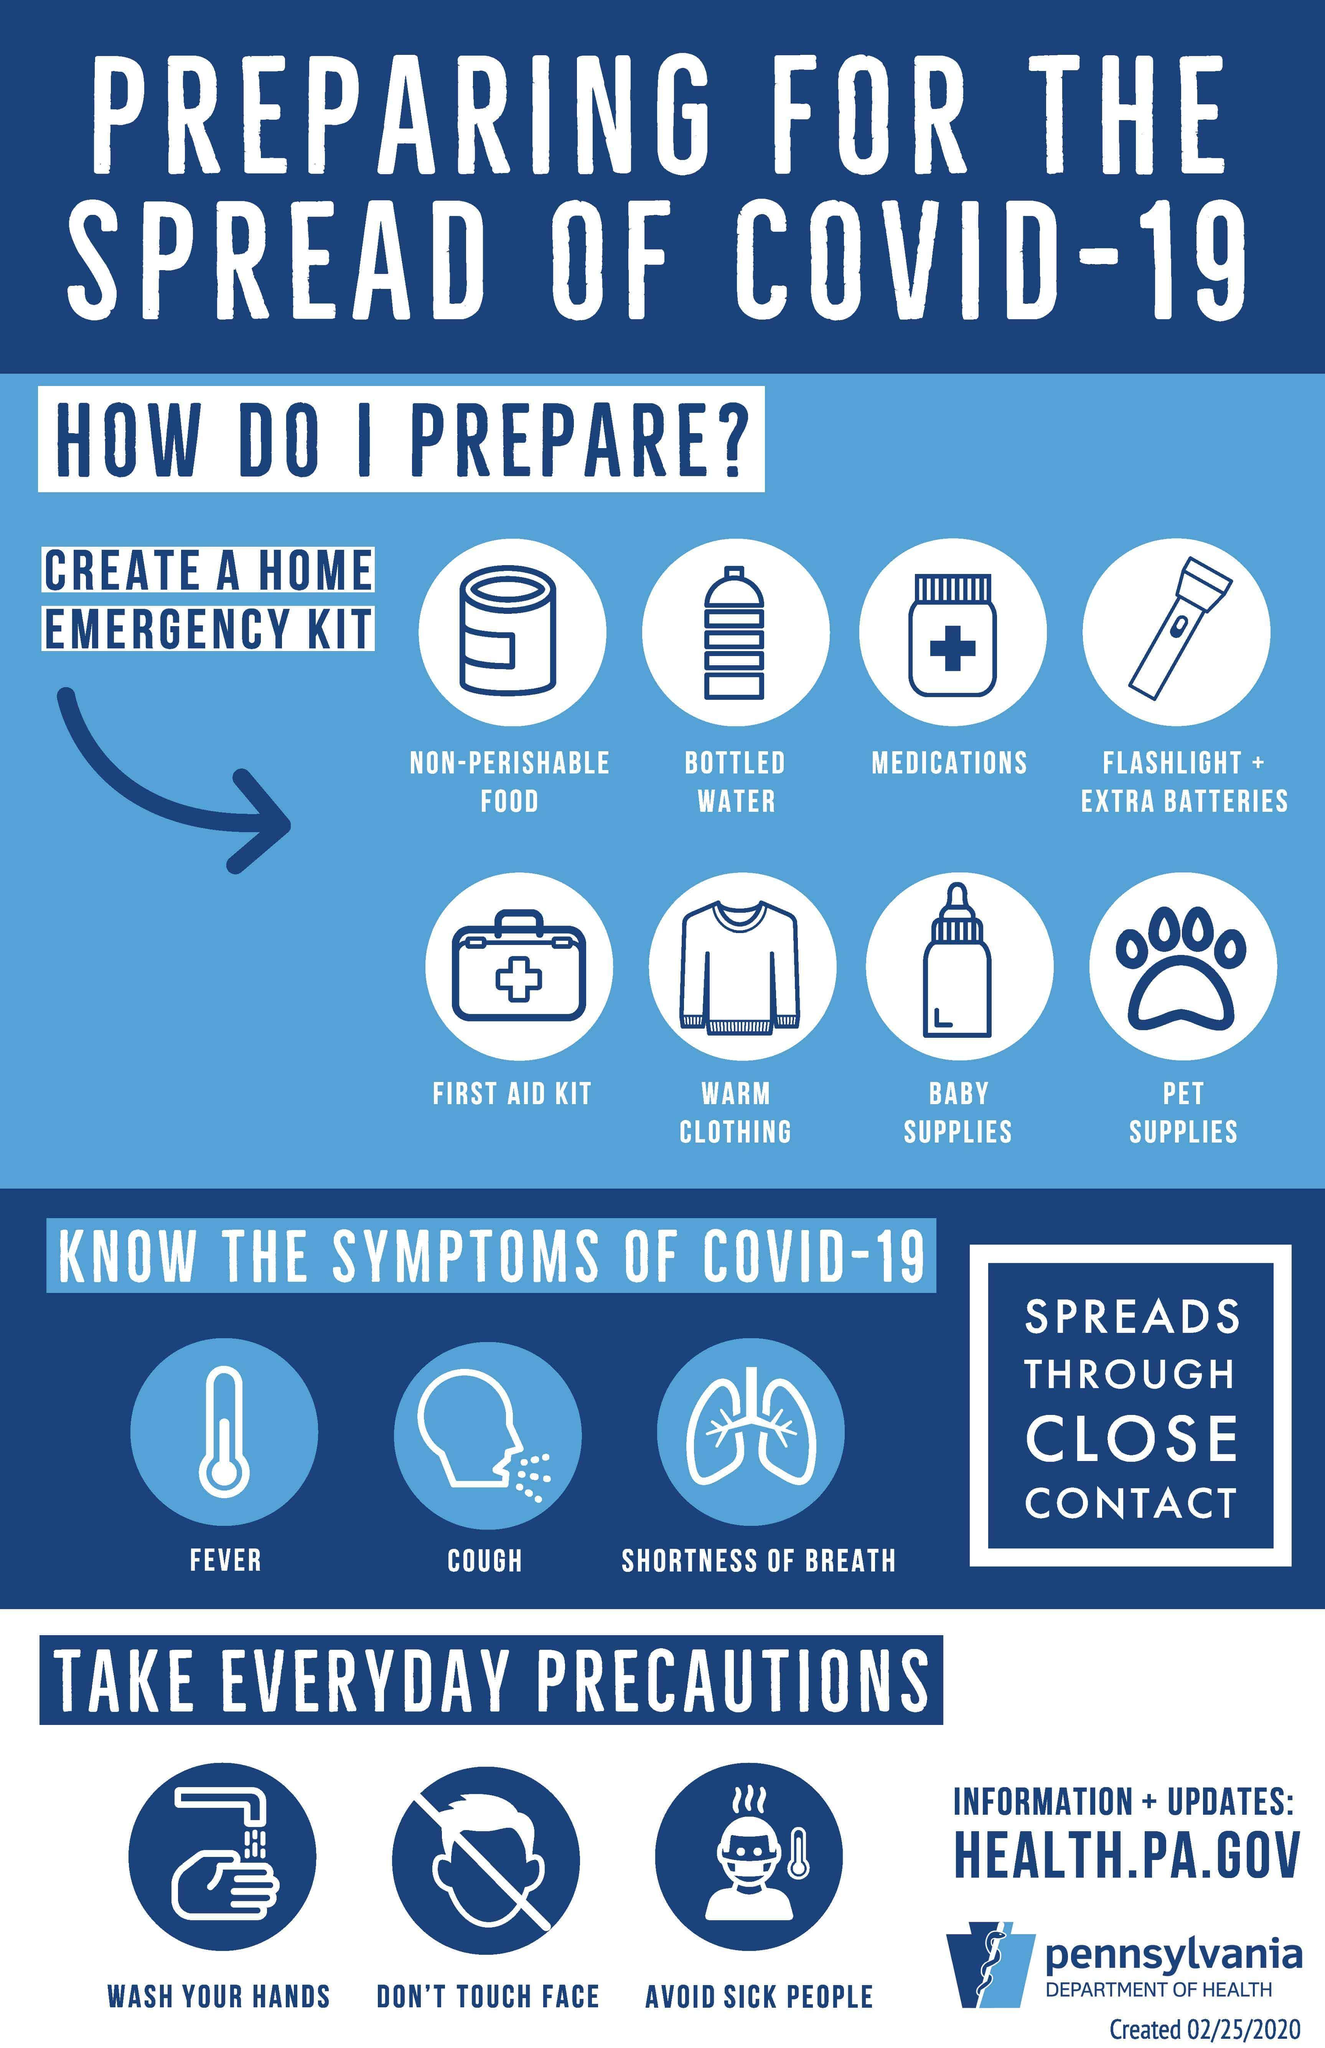Indicate a few pertinent items in this graphic. In order to prevent the spread of the coronavirus, it is essential to take precautionary measures such as washing your hands frequently and avoiding close contact with sick individuals. Additionally, covering your mouth and nose with a tissue or mask when coughing or sneezing, and avoiding touching your face, are crucial to reducing the risk of infection. In addition to fever and shortness of breath, COVID-19 can cause a persistent cough as a symptom. 